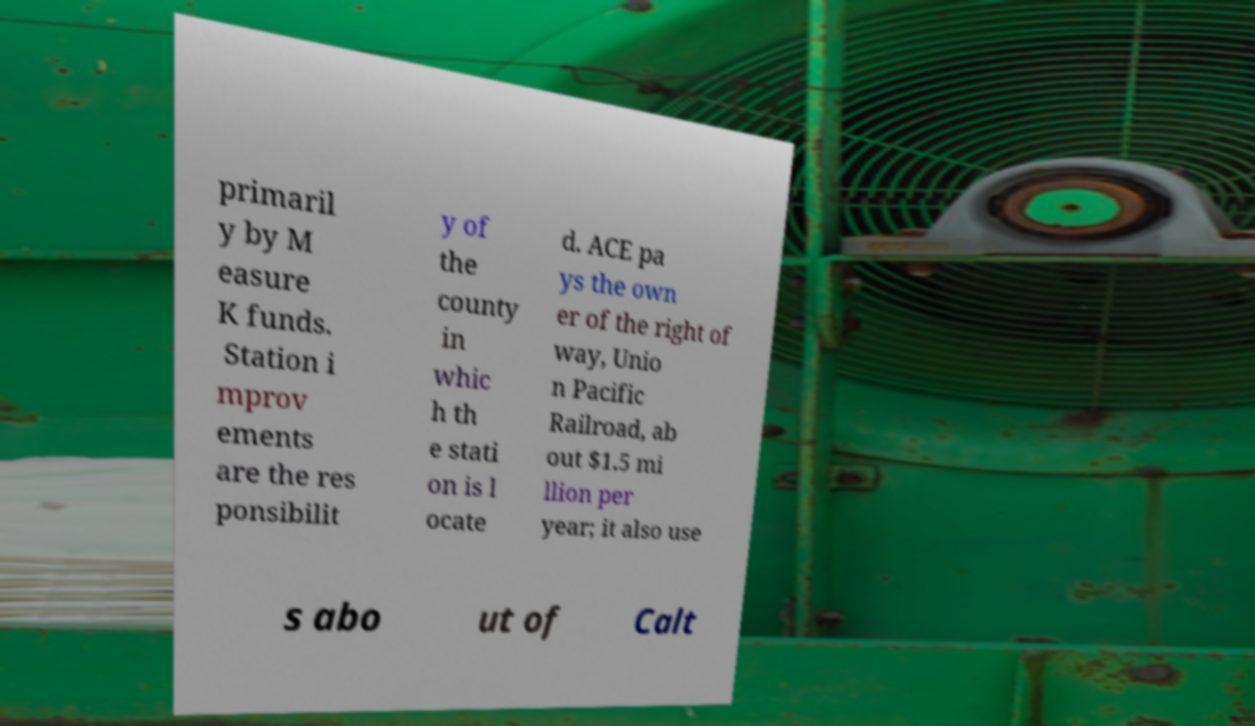What messages or text are displayed in this image? I need them in a readable, typed format. primaril y by M easure K funds. Station i mprov ements are the res ponsibilit y of the county in whic h th e stati on is l ocate d. ACE pa ys the own er of the right of way, Unio n Pacific Railroad, ab out $1.5 mi llion per year; it also use s abo ut of Calt 